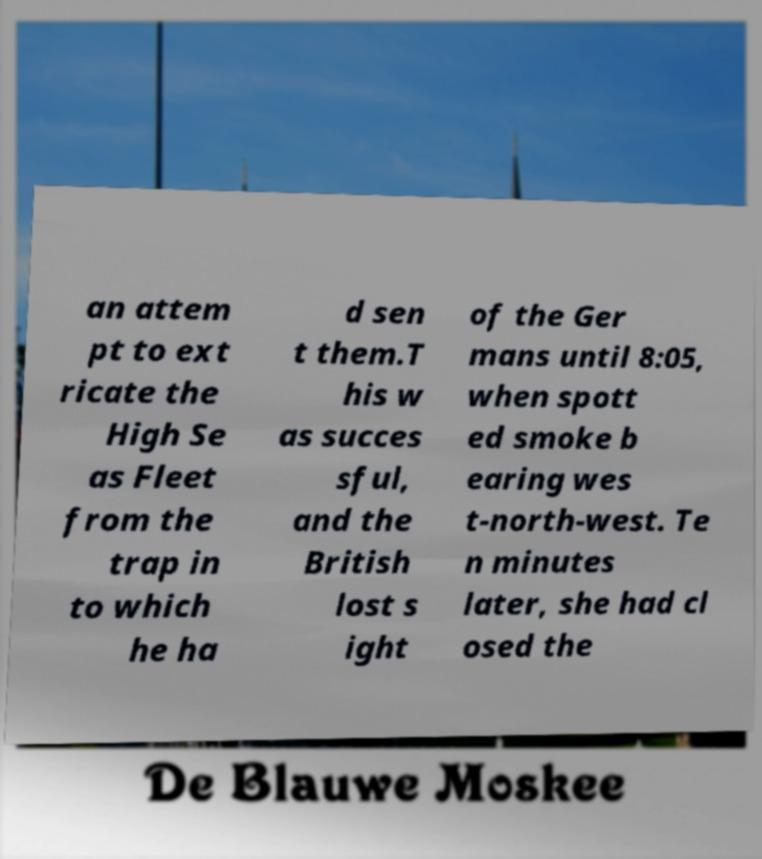Can you accurately transcribe the text from the provided image for me? an attem pt to ext ricate the High Se as Fleet from the trap in to which he ha d sen t them.T his w as succes sful, and the British lost s ight of the Ger mans until 8:05, when spott ed smoke b earing wes t-north-west. Te n minutes later, she had cl osed the 